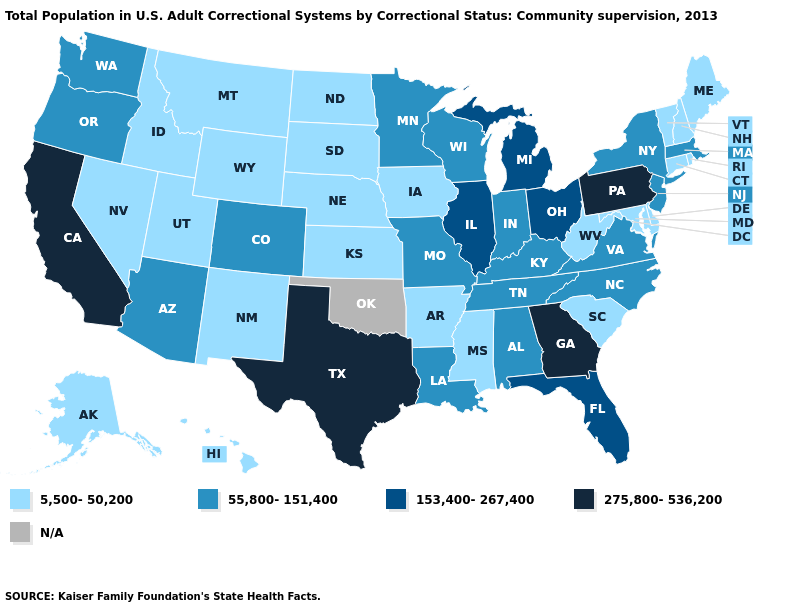Does the first symbol in the legend represent the smallest category?
Concise answer only. Yes. Is the legend a continuous bar?
Write a very short answer. No. Name the states that have a value in the range 5,500-50,200?
Concise answer only. Alaska, Arkansas, Connecticut, Delaware, Hawaii, Idaho, Iowa, Kansas, Maine, Maryland, Mississippi, Montana, Nebraska, Nevada, New Hampshire, New Mexico, North Dakota, Rhode Island, South Carolina, South Dakota, Utah, Vermont, West Virginia, Wyoming. Name the states that have a value in the range 275,800-536,200?
Short answer required. California, Georgia, Pennsylvania, Texas. Does the map have missing data?
Concise answer only. Yes. What is the value of New York?
Concise answer only. 55,800-151,400. Name the states that have a value in the range 5,500-50,200?
Answer briefly. Alaska, Arkansas, Connecticut, Delaware, Hawaii, Idaho, Iowa, Kansas, Maine, Maryland, Mississippi, Montana, Nebraska, Nevada, New Hampshire, New Mexico, North Dakota, Rhode Island, South Carolina, South Dakota, Utah, Vermont, West Virginia, Wyoming. What is the value of Massachusetts?
Write a very short answer. 55,800-151,400. What is the highest value in the USA?
Write a very short answer. 275,800-536,200. Does the map have missing data?
Quick response, please. Yes. Among the states that border New Hampshire , does Massachusetts have the highest value?
Write a very short answer. Yes. What is the value of Connecticut?
Short answer required. 5,500-50,200. Does the map have missing data?
Write a very short answer. Yes. 